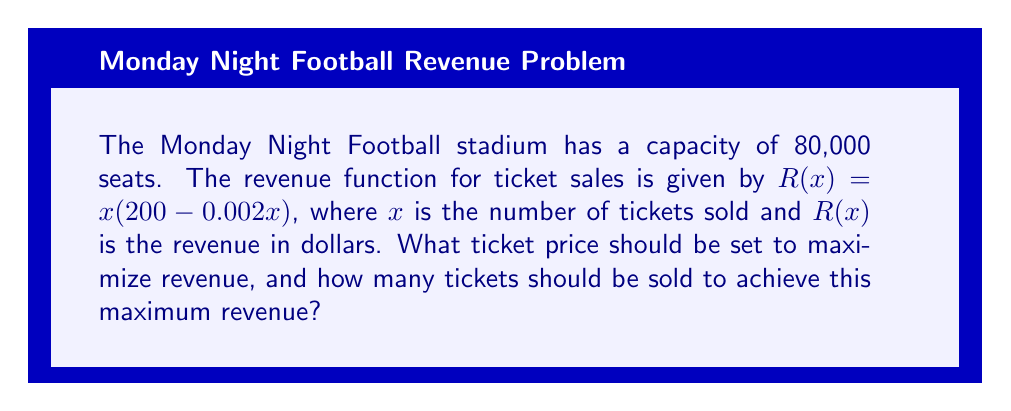Help me with this question. 1) First, let's understand the revenue function:
   $R(x) = x(200 - 0.002x) = 200x - 0.002x^2$

2) To find the maximum revenue, we need to find the derivative of $R(x)$ and set it to zero:
   $$\frac{dR}{dx} = 200 - 0.004x$$

3) Set this equal to zero and solve for $x$:
   $$200 - 0.004x = 0$$
   $$0.004x = 200$$
   $$x = 50,000$$

4) To confirm this is a maximum, check the second derivative:
   $$\frac{d^2R}{dx^2} = -0.004$$
   This is negative, confirming a maximum.

5) The optimal number of tickets to sell is 50,000.

6) To find the ticket price, substitute $x = 50,000$ into the original price function:
   $$p = 200 - 0.002(50,000) = 100$$

Therefore, the optimal ticket price is $100.

7) The maximum revenue can be calculated by substituting $x = 50,000$ into the revenue function:
   $$R(50,000) = 50,000(200 - 0.002(50,000)) = 5,000,000$$

The maximum revenue is $5,000,000.
Answer: Ticket price: $100; Number of tickets: 50,000 